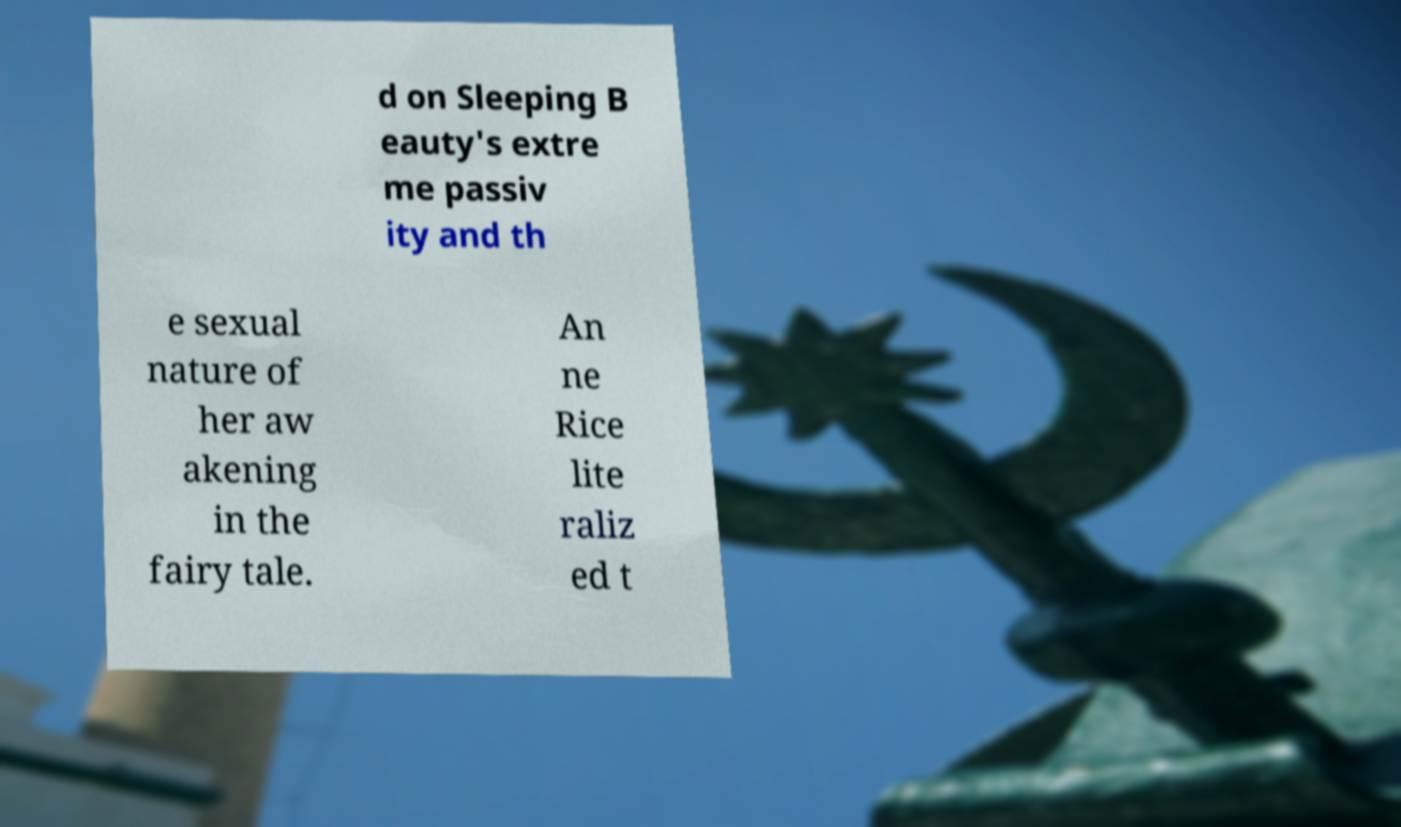Could you assist in decoding the text presented in this image and type it out clearly? d on Sleeping B eauty's extre me passiv ity and th e sexual nature of her aw akening in the fairy tale. An ne Rice lite raliz ed t 